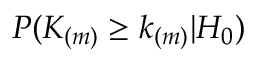<formula> <loc_0><loc_0><loc_500><loc_500>P ( K _ { ( m ) } \geq k _ { ( m ) } | H _ { 0 } )</formula> 